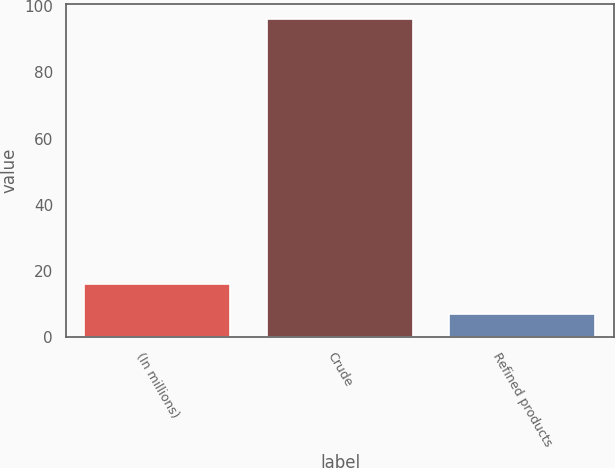Convert chart to OTSL. <chart><loc_0><loc_0><loc_500><loc_500><bar_chart><fcel>(In millions)<fcel>Crude<fcel>Refined products<nl><fcel>15.9<fcel>96<fcel>7<nl></chart> 